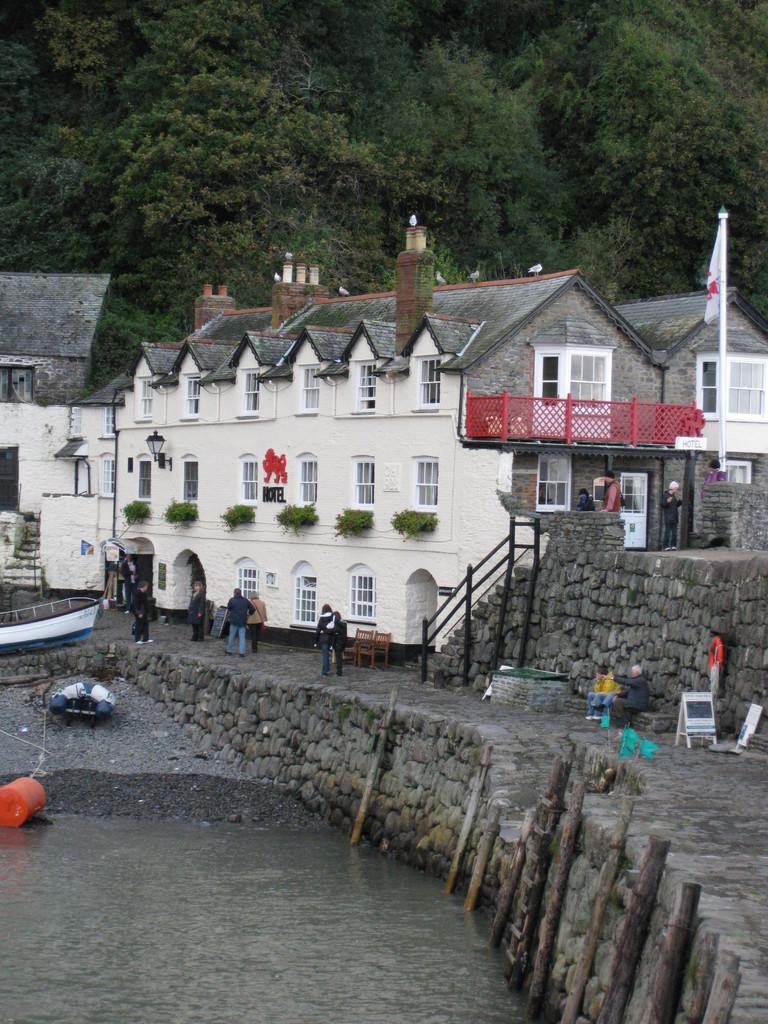Can you describe this image briefly? In this image, we can persons in front of the building. There is a flag on the right side of the image. There are poles in the water. There are some plants on the hill. There is a boat on the left side of the image. 